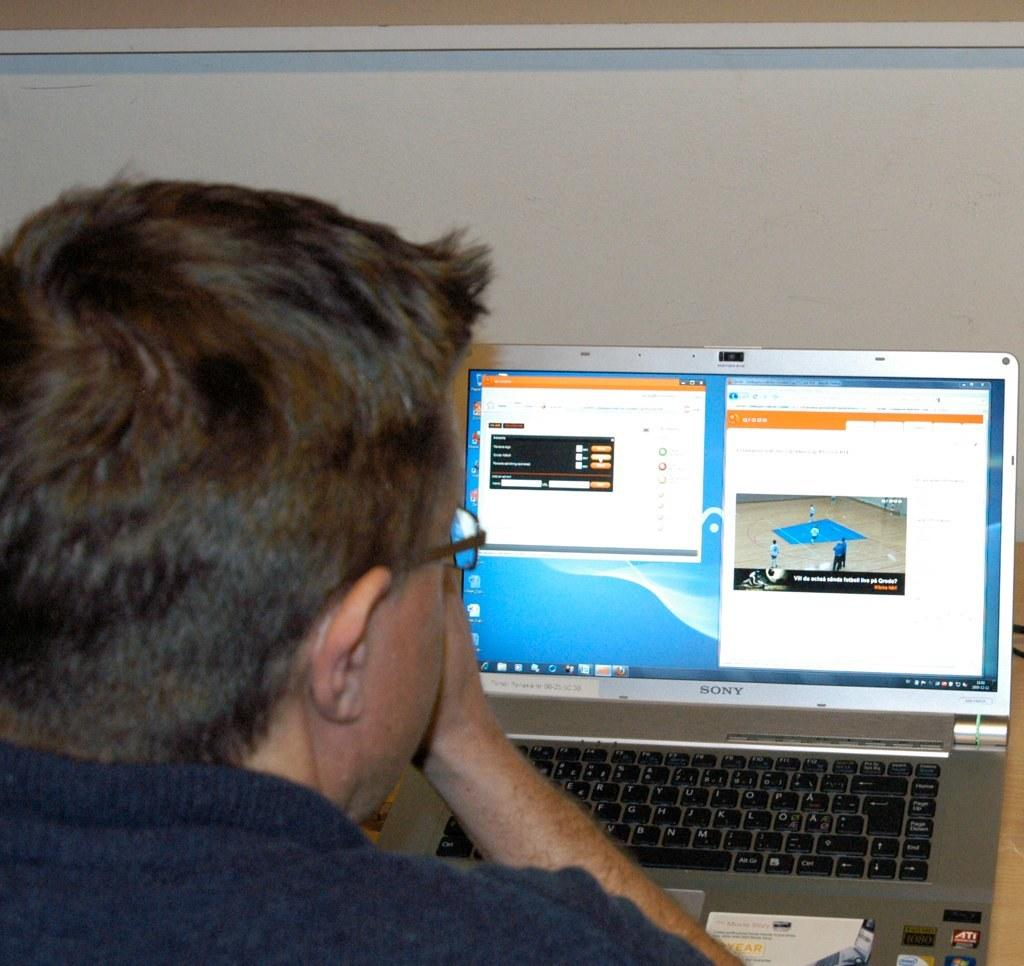<image>
Create a compact narrative representing the image presented. A man is looking at a monitor made by Sony. 